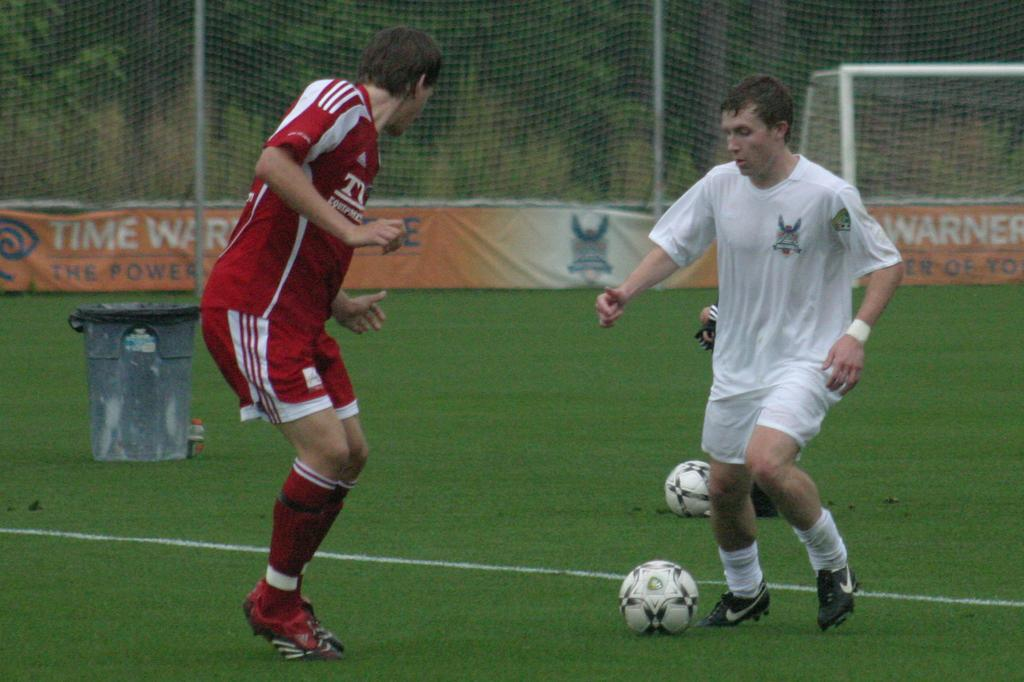<image>
Offer a succinct explanation of the picture presented. Two soccer players on a field with an orange banner sponsored by Time Warner. 